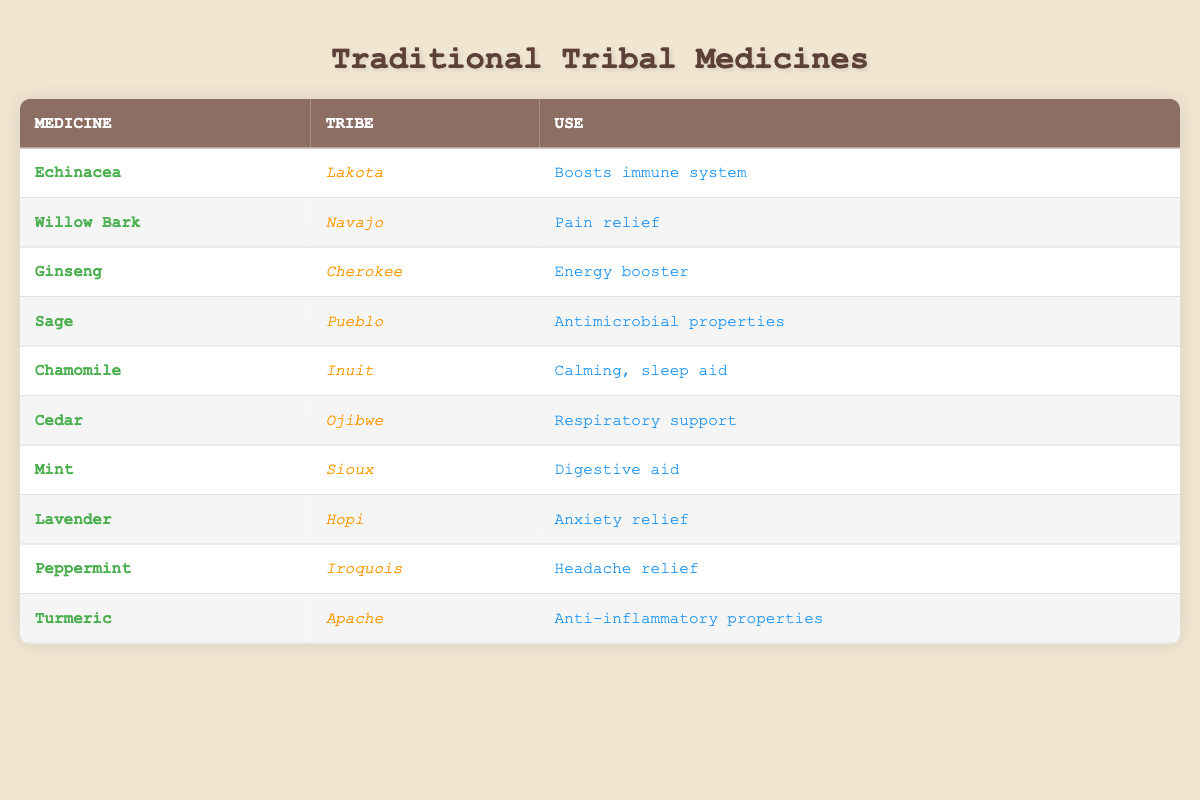What is the use of Echinacea? Referring to the table, Echinacea is listed under the "Use" column, which states that it "Boosts immune system."
Answer: Boosts immune system Which tribe uses Willow Bark? By looking at the "Tribe" column of Willow Bark in the table, we see it is associated with the "Navajo" tribe.
Answer: Navajo How many unique tribes are represented in this table? The unique tribes listed in the table are Lakota, Navajo, Cherokee, Pueblo, Inuit, Ojibwe, Sioux, Hopi, Iroquois, and Apache, totaling 10 tribes.
Answer: 10 Is there a medicine used for anxiety relief? The table indicates that Lavender is used for "Anxiety relief." This confirms that there is indeed a medicine used for this purpose.
Answer: Yes What are the total uses listed for the traditional medicines in this table? Each medicine in the table is paired with a specific use. Counting all individual entries, we find there are 10 uses listed as each medicine has a distinct application.
Answer: 10 How many traditional medicines are used for pain relief? Upon scanning the table, only Willow Bark is listed as a "Pain relief" medicine. Therefore, there is only one traditional medicine for this specific use.
Answer: 1 Which tribe uses Ginseng, and what is its primary use? Ginseng is associated with the "Cherokee" tribe, and according to the "Use" column, its primary use is as an "Energy booster."
Answer: Cherokee; Energy booster Does the table mention any traditional medicine used for respiratory support? The table clearly lists "Cedar" from the "Ojibwe" tribe as a traditional medicine used for "Respiratory support," confirming that there is such a medicine.
Answer: Yes How many traditional medicines are related to digestive aid? From reviewing the table, only "Mint," used by the "Sioux" tribe, is listed as a "Digestive aid." Thus, there is one traditional medicine related to digestive aid.
Answer: 1 